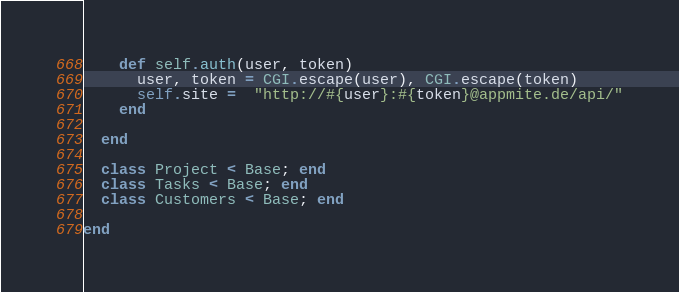Convert code to text. <code><loc_0><loc_0><loc_500><loc_500><_Ruby_>    def self.auth(user, token)
      user, token = CGI.escape(user), CGI.escape(token)
      self.site =  "http://#{user}:#{token}@appmite.de/api/"
    end    

  end

  class Project < Base; end
  class Tasks < Base; end
  class Customers < Base; end

end
</code> 